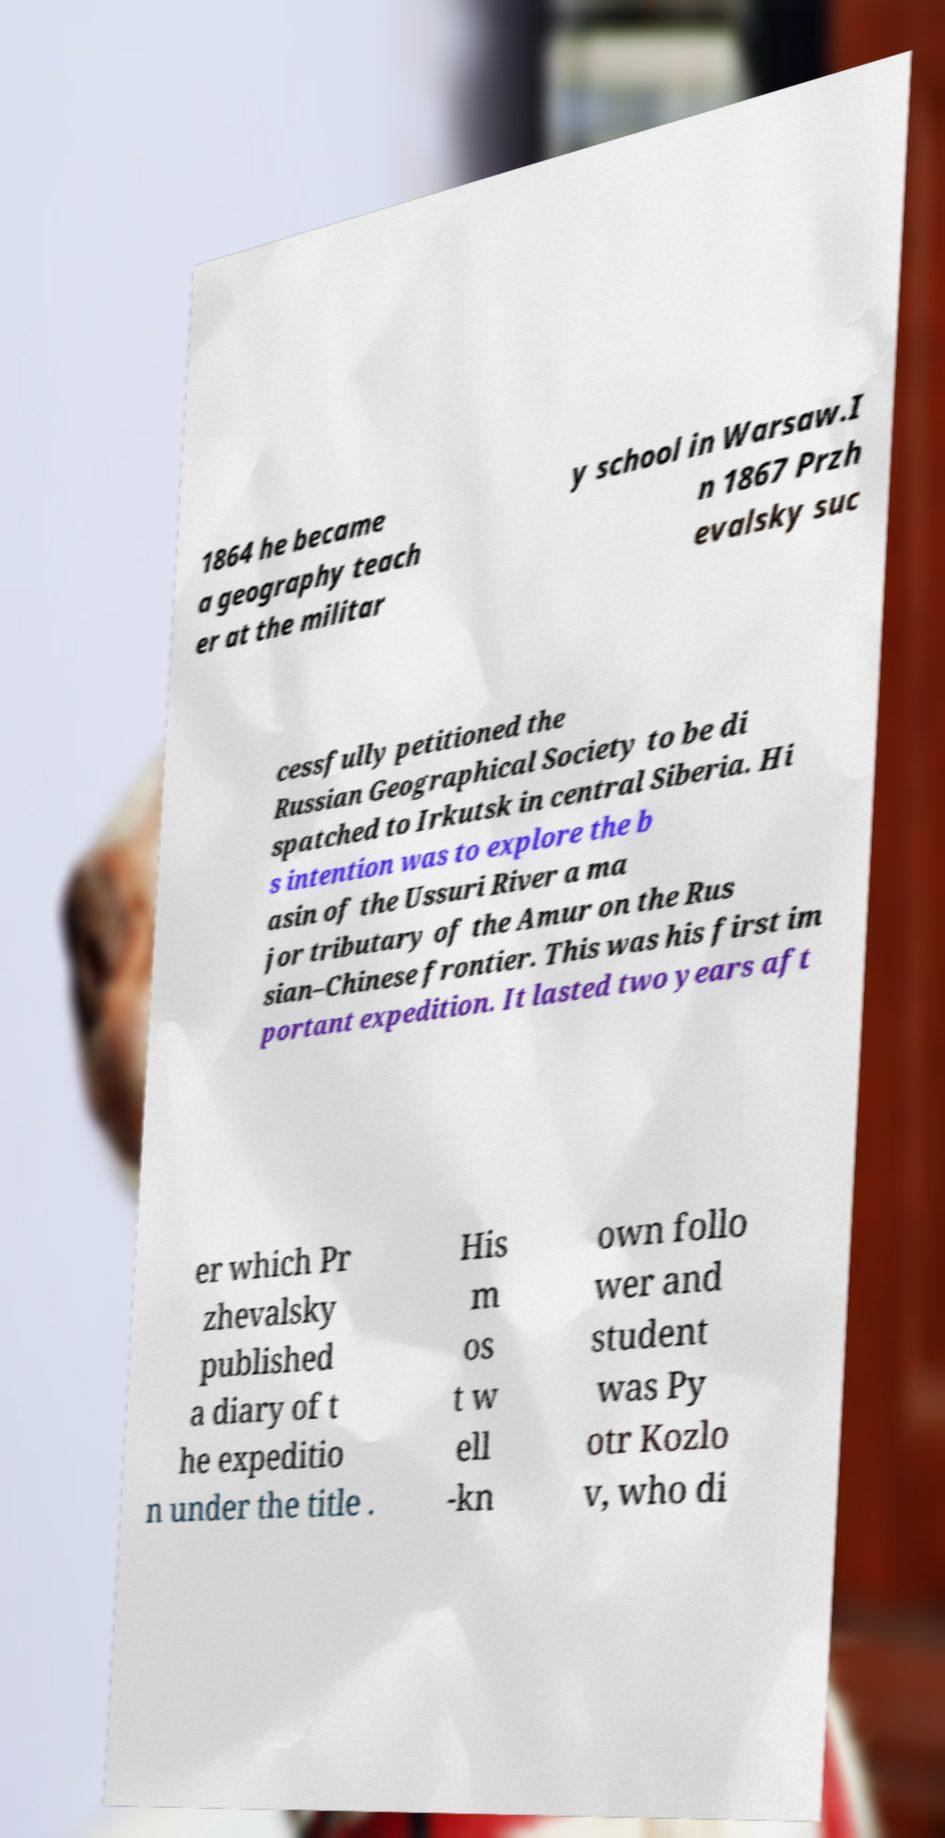Could you extract and type out the text from this image? 1864 he became a geography teach er at the militar y school in Warsaw.I n 1867 Przh evalsky suc cessfully petitioned the Russian Geographical Society to be di spatched to Irkutsk in central Siberia. Hi s intention was to explore the b asin of the Ussuri River a ma jor tributary of the Amur on the Rus sian–Chinese frontier. This was his first im portant expedition. It lasted two years aft er which Pr zhevalsky published a diary of t he expeditio n under the title . His m os t w ell -kn own follo wer and student was Py otr Kozlo v, who di 